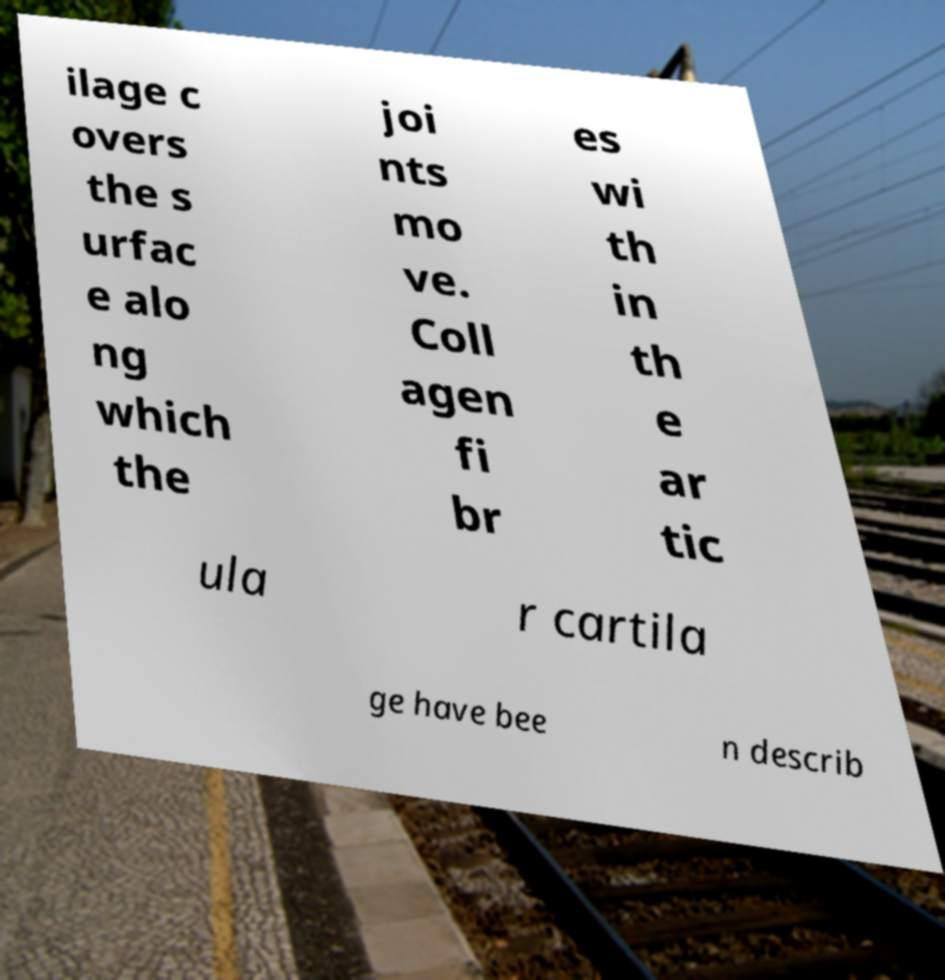What messages or text are displayed in this image? I need them in a readable, typed format. ilage c overs the s urfac e alo ng which the joi nts mo ve. Coll agen fi br es wi th in th e ar tic ula r cartila ge have bee n describ 